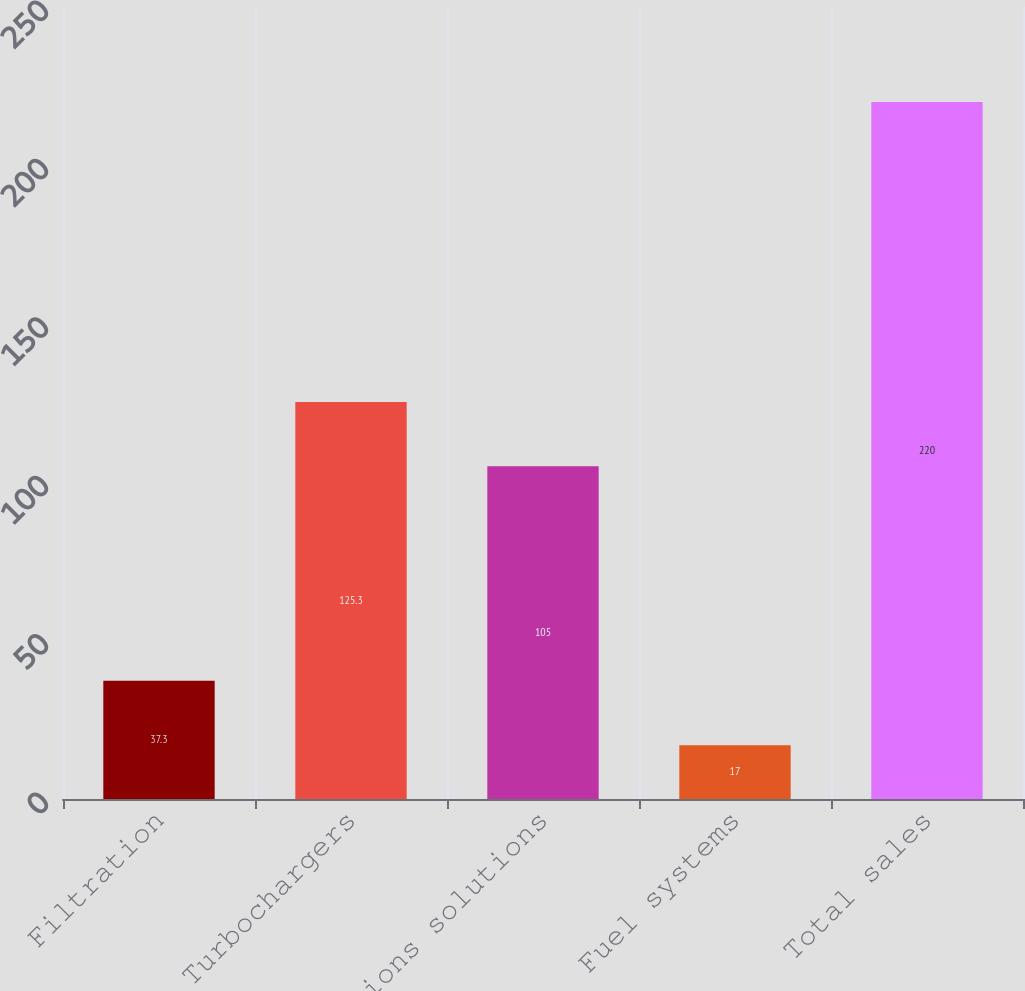Convert chart. <chart><loc_0><loc_0><loc_500><loc_500><bar_chart><fcel>Filtration<fcel>Turbochargers<fcel>Emissions solutions<fcel>Fuel systems<fcel>Total sales<nl><fcel>37.3<fcel>125.3<fcel>105<fcel>17<fcel>220<nl></chart> 